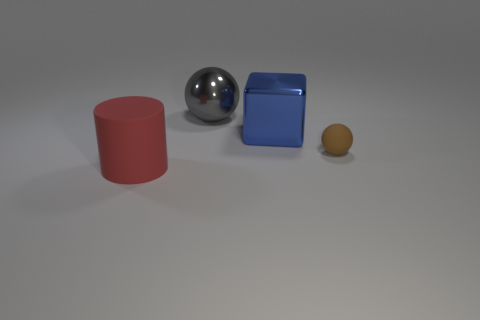Add 3 big purple metal blocks. How many objects exist? 7 Subtract all cylinders. How many objects are left? 3 Add 3 big blue balls. How many big blue balls exist? 3 Subtract 0 red blocks. How many objects are left? 4 Subtract all cyan rubber blocks. Subtract all big red things. How many objects are left? 3 Add 4 spheres. How many spheres are left? 6 